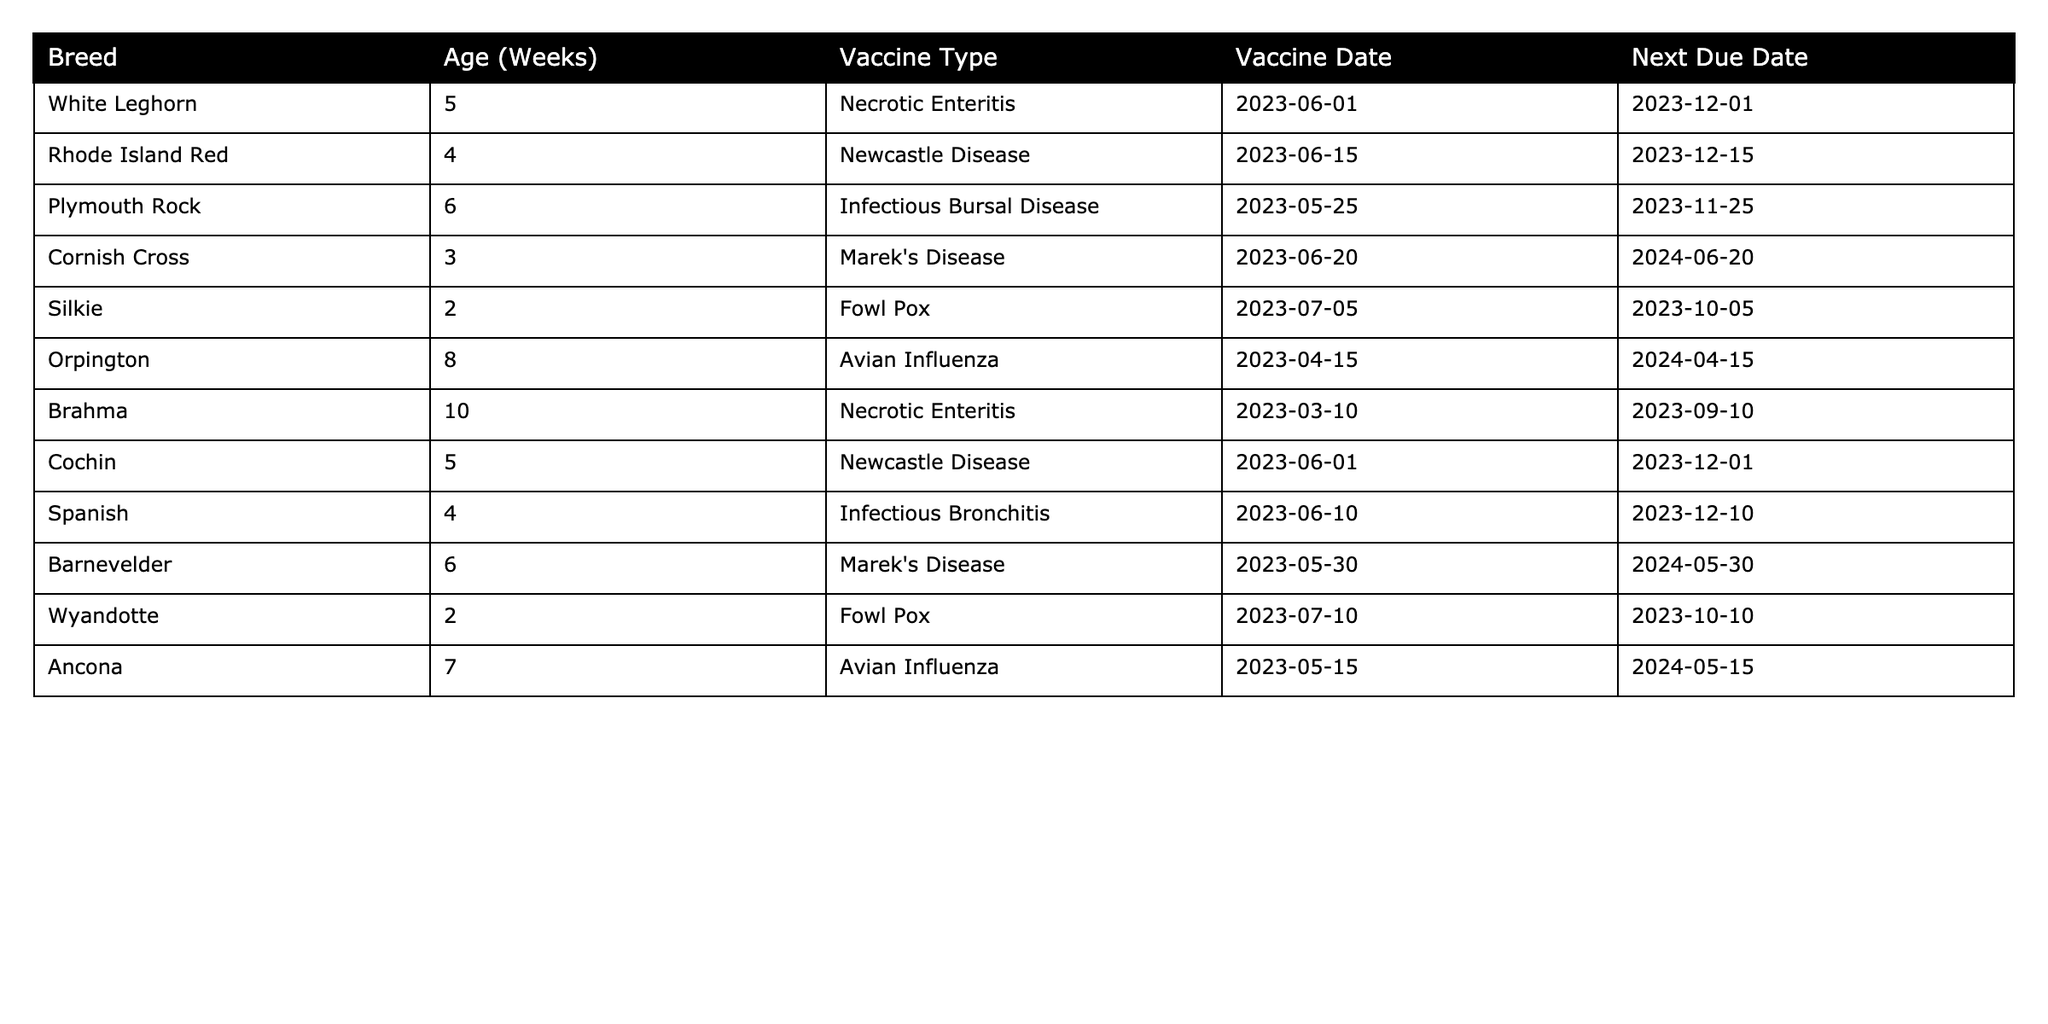What is the Next Due Date for the Rhode Island Red? The Next Due Date for the Rhode Island Red is listed in the table under that breed and is indicated as 2023-12-15.
Answer: 2023-12-15 How many weeks old are the youngest chickens in the table? The youngest chickens in the table are the Silkie and Wyandotte, both at 2 weeks old. Therefore, the answer is 2 weeks.
Answer: 2 weeks Which vaccine is administered to the oldest chickens, and what is their age? The oldest chickens in the data are the Brahma at 10 weeks old, vaccinated for Necrotic Enteritis. First, identify the breed and their age; then refer to the Vaccine Type column.
Answer: Necrotic Enteritis at 10 weeks Are there any breeds that have received the Marek's Disease vaccine? Yes, both the Cornish Cross and Barnevelder breeds have received the Marek's Disease vaccine. This is found by checking the Vaccine Type 'Marek's Disease' in the table against the listed breeds.
Answer: Yes What is the average age of the chickens vaccinated for Newcastle Disease? The age of the chickens for Newcastle Disease vaccines are the Rhode Island Red at 4 weeks and Cochin at 5 weeks. First, sum those ages (4 + 5 = 9) and then divide by the number of breeds (2) to find the average (9/2 = 4.5).
Answer: 4.5 weeks How many chickens are scheduled for vaccination in December 2023? Checking the Next Due Date column, the Rhode Island Red, White Leghorn, Cochin, and Spanish have due dates in December (2023-12-15, 2023-12-01, 2023-12-01, and 2023-12-10 respectively). This totals four chickens.
Answer: 4 Which vaccine type is due next for the Cornish Cross chicken? The Cornish Cross chicken is due for Marek's Disease vaccination, as indicated in the Vaccine Type column pertaining to that breed.
Answer: Marek's Disease Is there a breed that has received the Fowl Pox vaccination? Yes, both the Silkie and Wyandotte breeds have been vaccinated against Fowl Pox. This can be confirmed by checking the Vaccine Type for these breeds.
Answer: Yes What is the difference in weeks between the oldest and youngest chicken in the table? The oldest chicken is 10 weeks (Brahma), and the youngest is 2 weeks (Silkie and Wyandotte). Calculate the difference: 10 - 2 = 8 weeks.
Answer: 8 weeks How many different vaccine types are listed for the chickens? The vaccine types listed in the table are Necrotic Enteritis, Newcastle Disease, Infectious Bursal Disease, Marek's Disease, Fowl Pox, Avian Influenza, and Infectious Bronchitis. Counting those gives us a total of 7 distinct types.
Answer: 7 Which breed has its Next Due Date earliest among those vaccinated for Avian Influenza? The only breed vaccinated for Avian Influenza is Orpington, with a Next Due Date of 2024-04-15. There are no earlier dates for other breeds since only Orpington is listed for Avian Influenza.
Answer: Orpington 